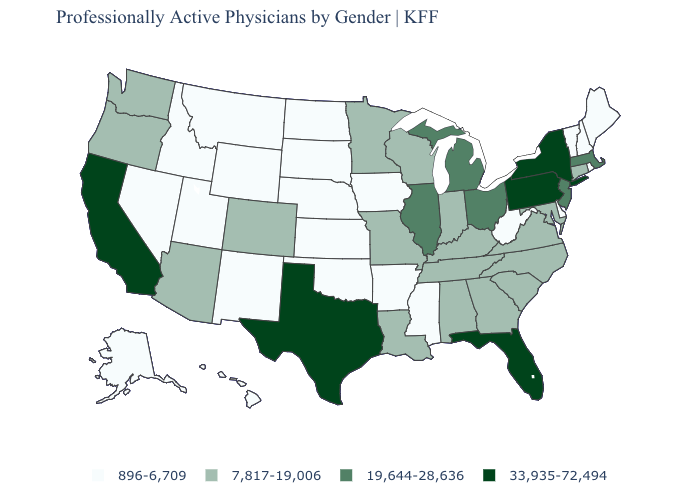Does the map have missing data?
Answer briefly. No. Does Vermont have the same value as Connecticut?
Be succinct. No. Among the states that border New Jersey , does Pennsylvania have the highest value?
Keep it brief. Yes. What is the lowest value in the West?
Short answer required. 896-6,709. Does the first symbol in the legend represent the smallest category?
Give a very brief answer. Yes. What is the value of Alaska?
Answer briefly. 896-6,709. Does Iowa have the lowest value in the MidWest?
Quick response, please. Yes. Among the states that border Nevada , which have the highest value?
Short answer required. California. Name the states that have a value in the range 896-6,709?
Short answer required. Alaska, Arkansas, Delaware, Hawaii, Idaho, Iowa, Kansas, Maine, Mississippi, Montana, Nebraska, Nevada, New Hampshire, New Mexico, North Dakota, Oklahoma, Rhode Island, South Dakota, Utah, Vermont, West Virginia, Wyoming. Does the map have missing data?
Give a very brief answer. No. Does Texas have a lower value than Colorado?
Give a very brief answer. No. Among the states that border Rhode Island , which have the lowest value?
Quick response, please. Connecticut. What is the highest value in the USA?
Concise answer only. 33,935-72,494. Does Kentucky have the lowest value in the USA?
Keep it brief. No. Does Illinois have a lower value than New York?
Keep it brief. Yes. 